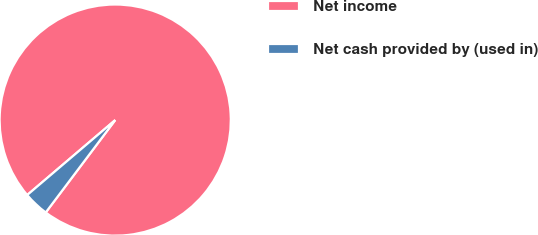<chart> <loc_0><loc_0><loc_500><loc_500><pie_chart><fcel>Net income<fcel>Net cash provided by (used in)<nl><fcel>96.49%<fcel>3.51%<nl></chart> 